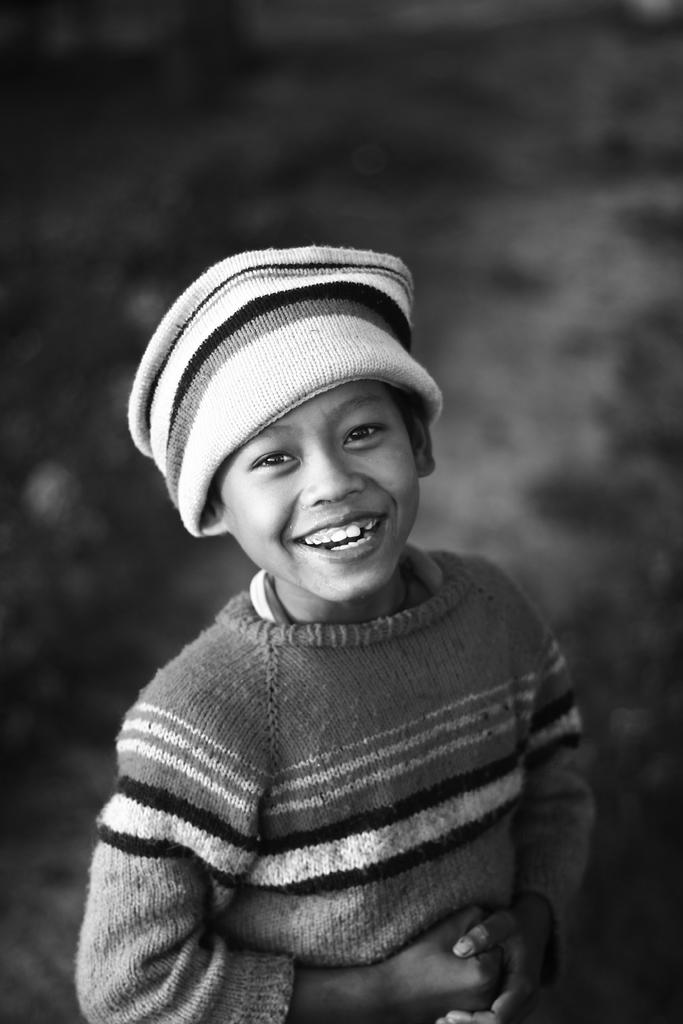What is the main subject of the image? The main subject of the image is a kid standing. What is the kid wearing in the image? The kid is wearing a sweater and a cap in the image. What is the color scheme of the image? The image is in black and white color. What type of food can be seen on the hill in the image? There is no hill or food present in the image; it features a kid standing while wearing a sweater and a cap. 